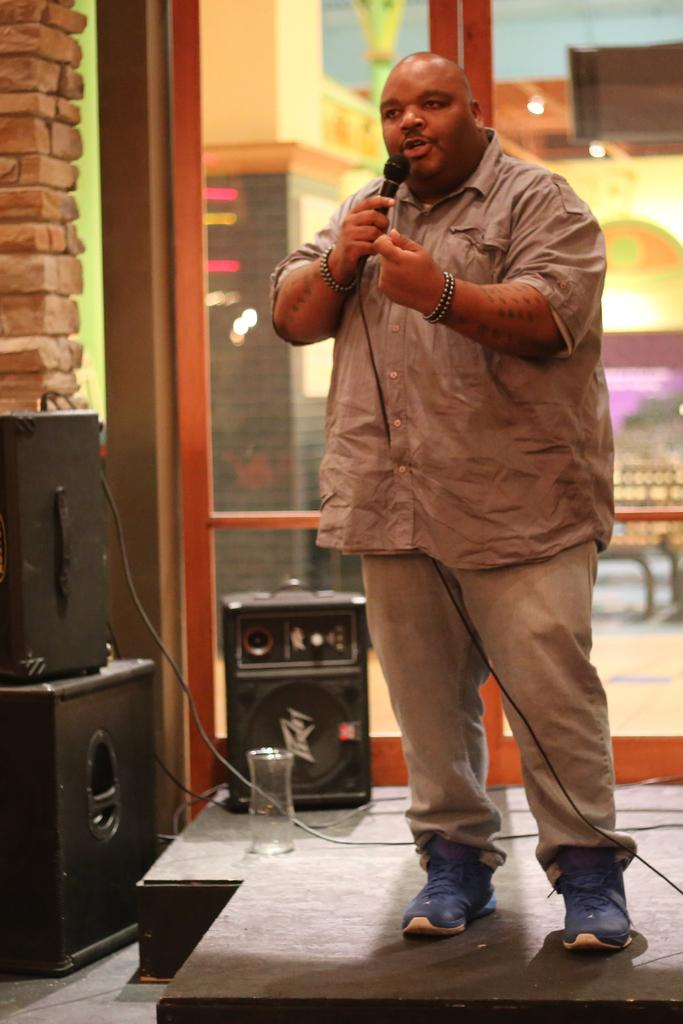What is the man in the image holding? The man is holding a mic. Where is the man located in the image? The man is standing on the stage. What can be seen in the background of the image? There are speakers, a wall, and a window in the background of the image. What type of yarn is being used to create the line in the sky in the image? There is no line or yarn present in the sky in the image. 